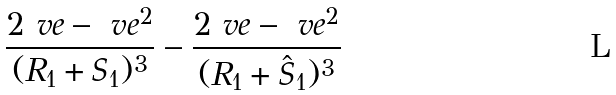Convert formula to latex. <formula><loc_0><loc_0><loc_500><loc_500>\frac { 2 \ v e - \ v e ^ { 2 } } { ( R _ { 1 } + S _ { 1 } ) ^ { 3 } } - \frac { 2 \ v e - \ v e ^ { 2 } } { ( R _ { 1 } + \hat { S } _ { 1 } ) ^ { 3 } }</formula> 